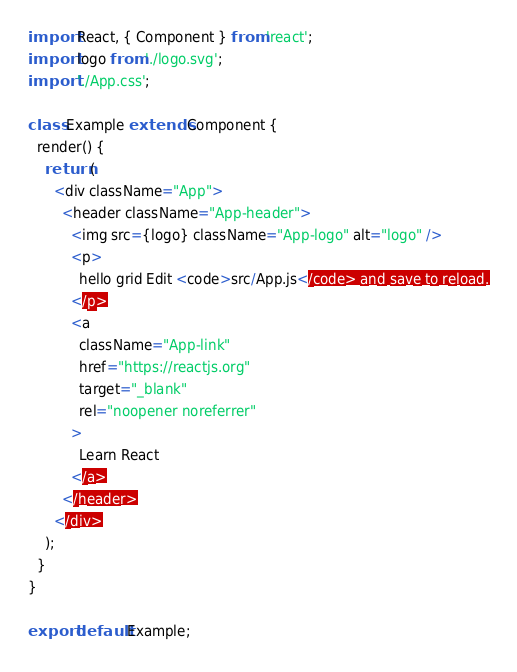Convert code to text. <code><loc_0><loc_0><loc_500><loc_500><_JavaScript_>import React, { Component } from 'react';
import logo from './logo.svg';
import './App.css';

class Example extends Component {
  render() {
    return (
      <div className="App">
        <header className="App-header">
          <img src={logo} className="App-logo" alt="logo" />
          <p>
            hello grid Edit <code>src/App.js</code> and save to reload.
          </p>
          <a
            className="App-link"
            href="https://reactjs.org"
            target="_blank"
            rel="noopener noreferrer"
          >
            Learn React
          </a>
        </header>
      </div>
    );
  }
}

export default Example;
</code> 